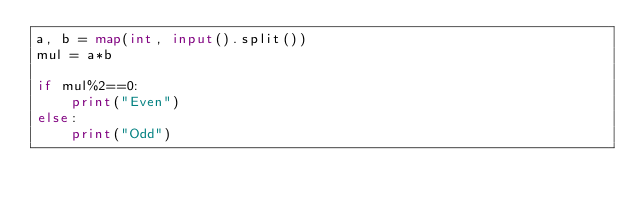Convert code to text. <code><loc_0><loc_0><loc_500><loc_500><_Python_>a, b = map(int, input().split())
mul = a*b

if mul%2==0:
    print("Even")
else:
    print("Odd")</code> 